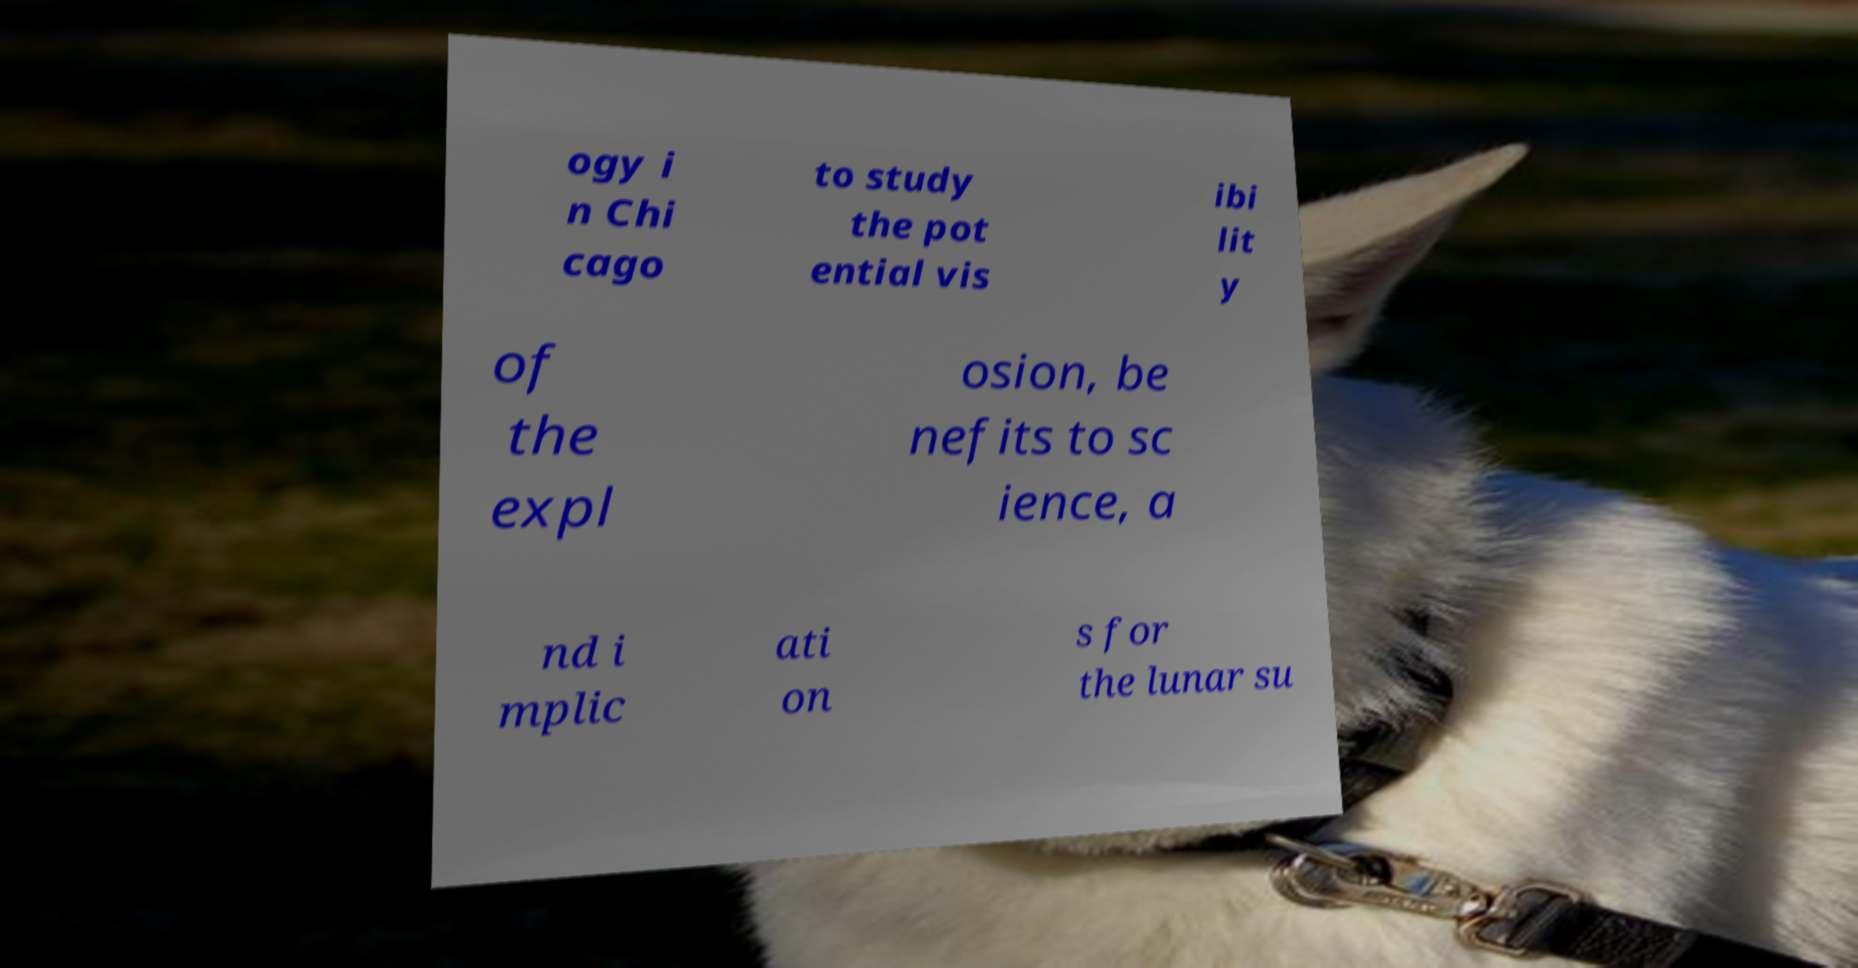There's text embedded in this image that I need extracted. Can you transcribe it verbatim? ogy i n Chi cago to study the pot ential vis ibi lit y of the expl osion, be nefits to sc ience, a nd i mplic ati on s for the lunar su 